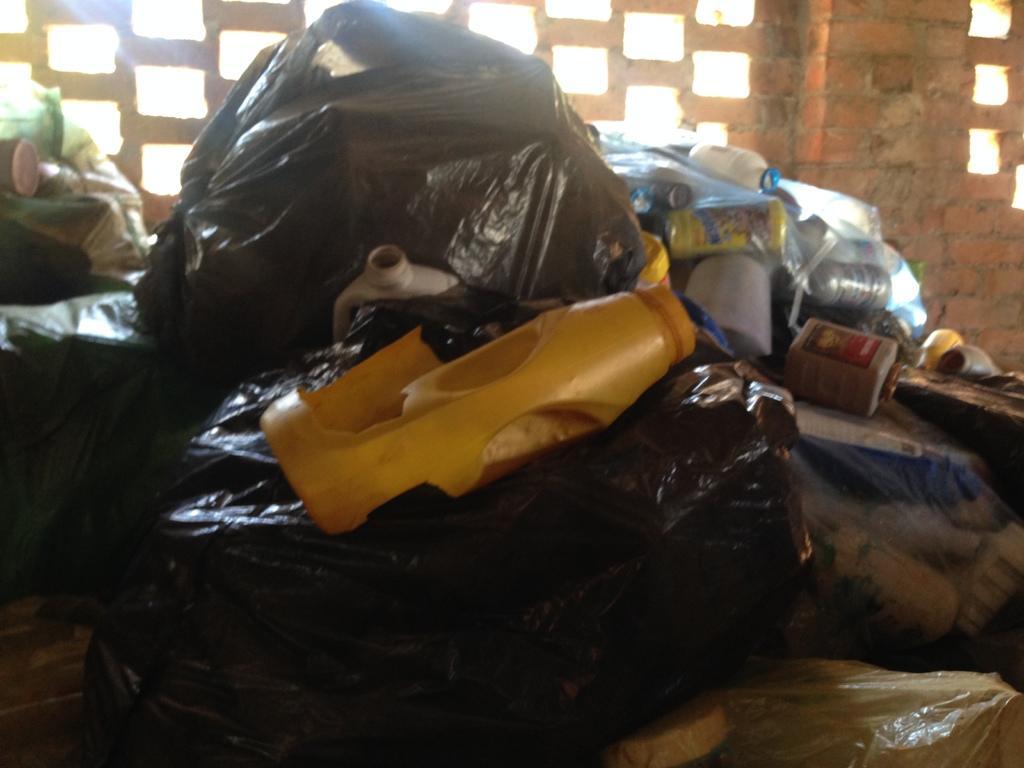Could you give a brief overview of what you see in this image? In the background we can see the brick wall and there are gaps. In this picture we can see black polythene covers, bottles and few other objects. 